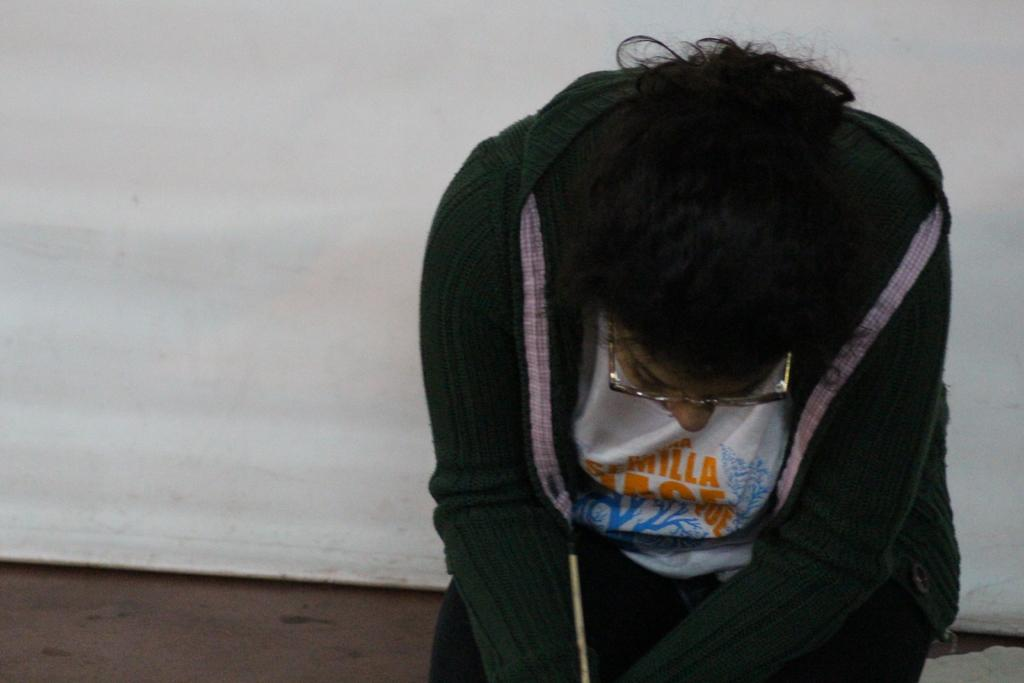Who is present in the image? There is a person in the image. What is the person doing in the image? The person is sitting on the floor. What type of trick is the person performing in the image? There is no trick being performed in the image; the person is simply sitting on the floor. 